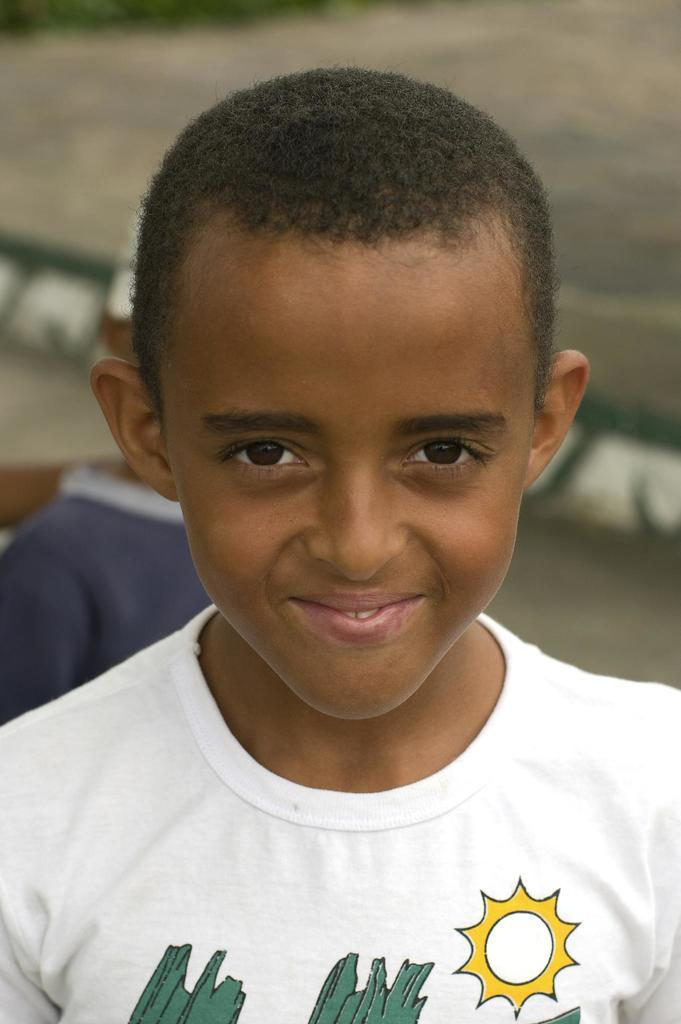Who is present in the image? There is a boy in the image. What is the boy's facial expression? The boy is smiling. Can you describe the background of the image? The background of the image is blurred. What type of polish is the boy applying to his bead in the image? There is no polish or bead present in the image; it features a boy who is smiling. What knowledge can be gained from the boy's expression in the image? The boy's expression in the image suggests happiness or enjoyment, but it does not convey any specific knowledge. 